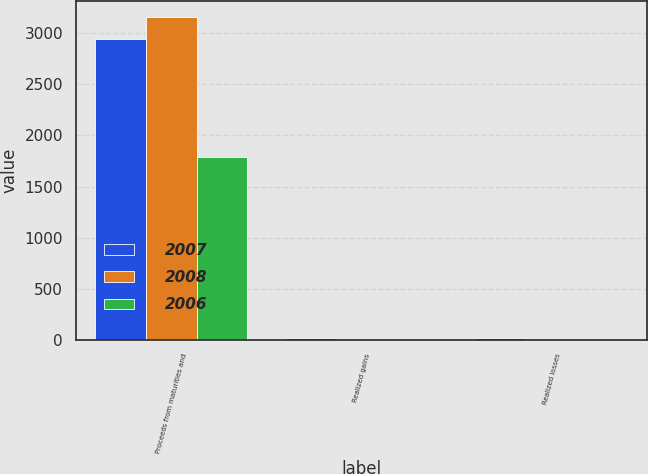Convert chart. <chart><loc_0><loc_0><loc_500><loc_500><stacked_bar_chart><ecel><fcel>Proceeds from maturities and<fcel>Realized gains<fcel>Realized losses<nl><fcel>2007<fcel>2941.1<fcel>15.9<fcel>17<nl><fcel>2008<fcel>3154.3<fcel>4.5<fcel>4.9<nl><fcel>2006<fcel>1787.1<fcel>1.9<fcel>4.7<nl></chart> 